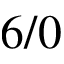<formula> <loc_0><loc_0><loc_500><loc_500>6 / 0</formula> 